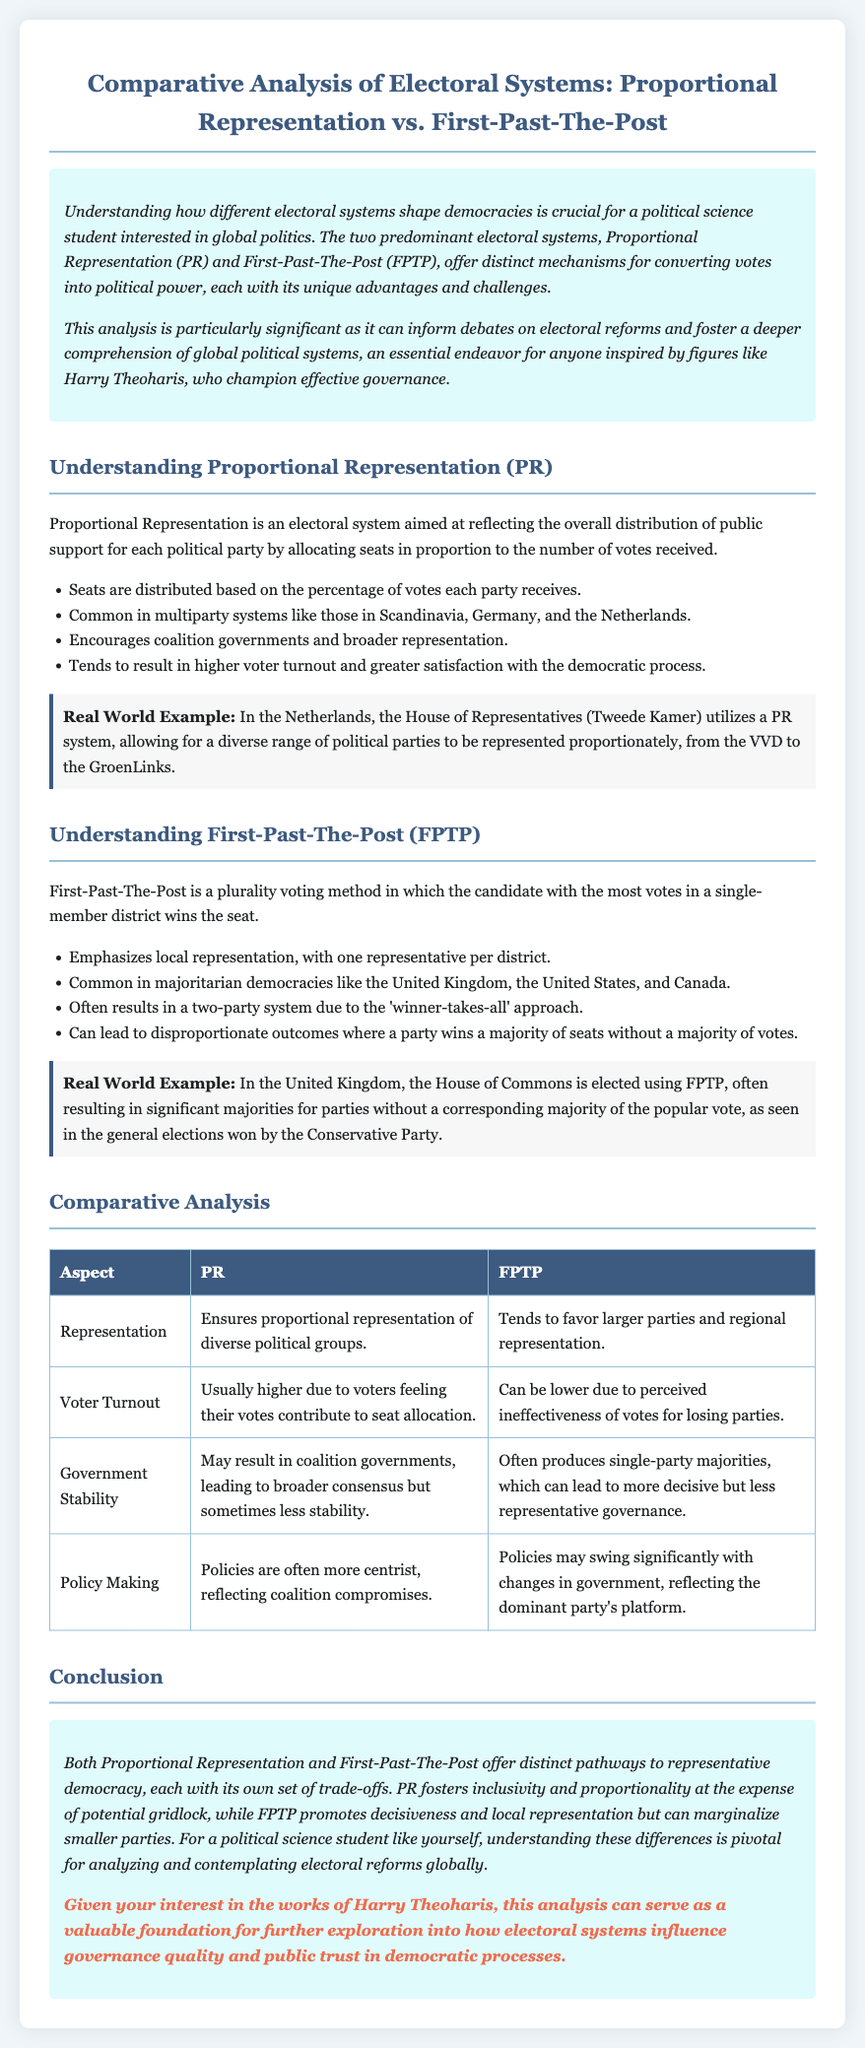What is Proportional Representation (PR)? Proportional Representation is an electoral system aimed at reflecting the overall distribution of public support for each political party by allocating seats in proportion to the number of votes received.
Answer: An electoral system aimed at reflecting the overall distribution of public support What is First-Past-The-Post (FPTP)? First-Past-The-Post is a plurality voting method in which the candidate with the most votes in a single-member district wins the seat.
Answer: A plurality voting method where the candidate with the most votes wins Which countries commonly use Proportional Representation? The document lists countries such as Scandinavia, Germany, and the Netherlands as common examples of PR systems.
Answer: Scandinavia, Germany, and the Netherlands What is one potential outcome of FPTP mentioned in the document? The document states that FPTP can lead to disproportionate outcomes where a party wins a majority of seats without a majority of votes.
Answer: Disproportionate outcomes What aspect does PR provide that FPTP does not? The document highlights that PR ensures proportional representation of diverse political groups, which FPTP does not.
Answer: Proportional representation of diverse political groups Which voting system can lead to coalition governments? The document indicates that Proportional Representation often leads to coalition governments.
Answer: Proportional Representation What is a characteristic of voter turnout in PR systems? The document mentions that voter turnout in PR systems is usually higher due to voters feeling their votes contribute to seat allocation.
Answer: Usually higher What can be a consequence of FPTP on policy making? According to the document, policies may swing significantly with changes in government, reflecting the dominant party's platform.
Answer: Policies may swing significantly How is this analysis related to Harry Theoharis? The document connects this analysis to Harry Theoharis as relevant for exploring how electoral systems influence governance quality and public trust.
Answer: It informs the analysis of governance quality and public trust 